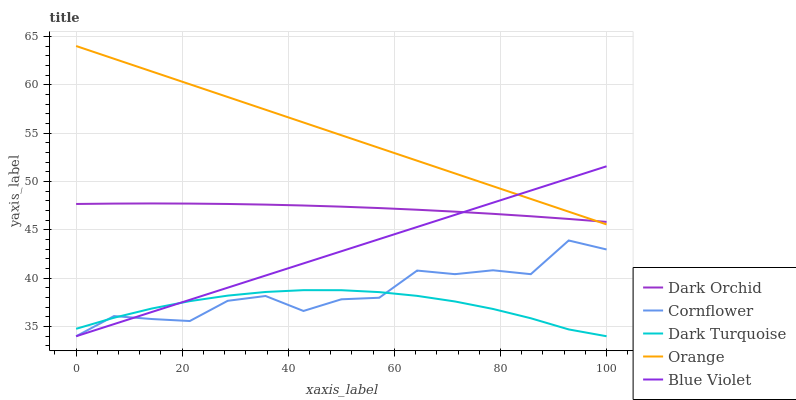Does Cornflower have the minimum area under the curve?
Answer yes or no. No. Does Cornflower have the maximum area under the curve?
Answer yes or no. No. Is Cornflower the smoothest?
Answer yes or no. No. Is Blue Violet the roughest?
Answer yes or no. No. Does Dark Orchid have the lowest value?
Answer yes or no. No. Does Cornflower have the highest value?
Answer yes or no. No. Is Dark Turquoise less than Orange?
Answer yes or no. Yes. Is Orange greater than Dark Turquoise?
Answer yes or no. Yes. Does Dark Turquoise intersect Orange?
Answer yes or no. No. 